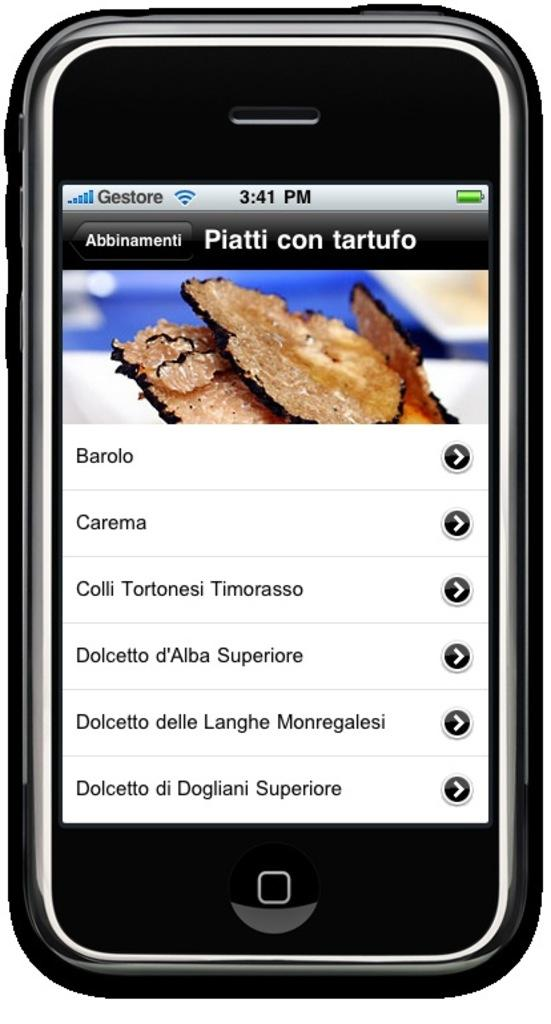Provide a one-sentence caption for the provided image. Piatti con tartufo is displayed on a cellular phone screen at 3:41 pm. 